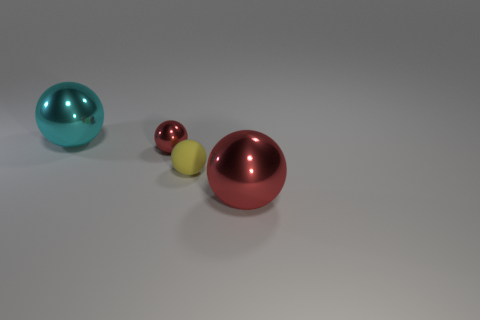Is there anything else that is the same material as the tiny yellow ball?
Provide a short and direct response. No. There is a thing that is both behind the small rubber ball and right of the cyan shiny ball; what material is it?
Offer a terse response. Metal. Is the number of small yellow rubber things in front of the big cyan metal thing greater than the number of brown shiny blocks?
Ensure brevity in your answer.  Yes. What number of red balls are the same size as the cyan object?
Your answer should be very brief. 1. What size is the other metal sphere that is the same color as the tiny metal sphere?
Your response must be concise. Large. How many tiny objects are either yellow spheres or red metal objects?
Offer a terse response. 2. What number of metal balls are there?
Your response must be concise. 3. Is the number of objects left of the tiny yellow sphere the same as the number of large red things to the left of the small metallic sphere?
Your answer should be very brief. No. Are there any small balls to the right of the tiny matte thing?
Offer a very short reply. No. What is the color of the large sphere that is behind the large red object?
Your response must be concise. Cyan. 